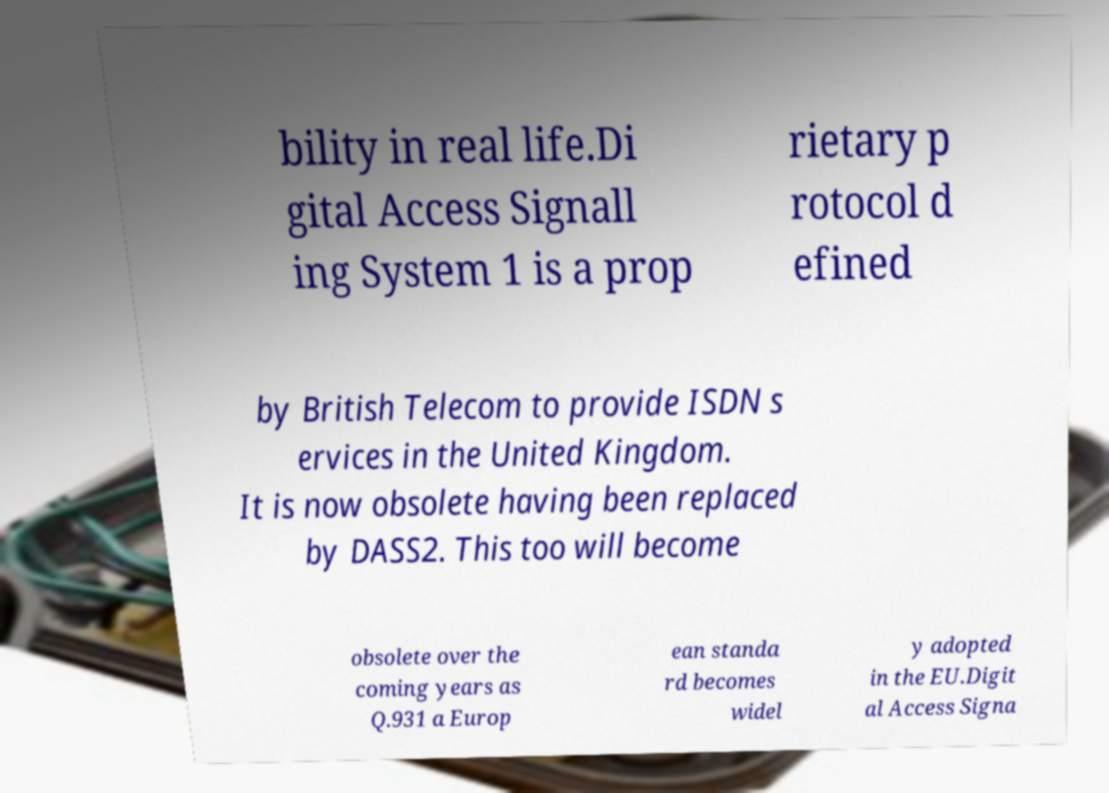What messages or text are displayed in this image? I need them in a readable, typed format. bility in real life.Di gital Access Signall ing System 1 is a prop rietary p rotocol d efined by British Telecom to provide ISDN s ervices in the United Kingdom. It is now obsolete having been replaced by DASS2. This too will become obsolete over the coming years as Q.931 a Europ ean standa rd becomes widel y adopted in the EU.Digit al Access Signa 